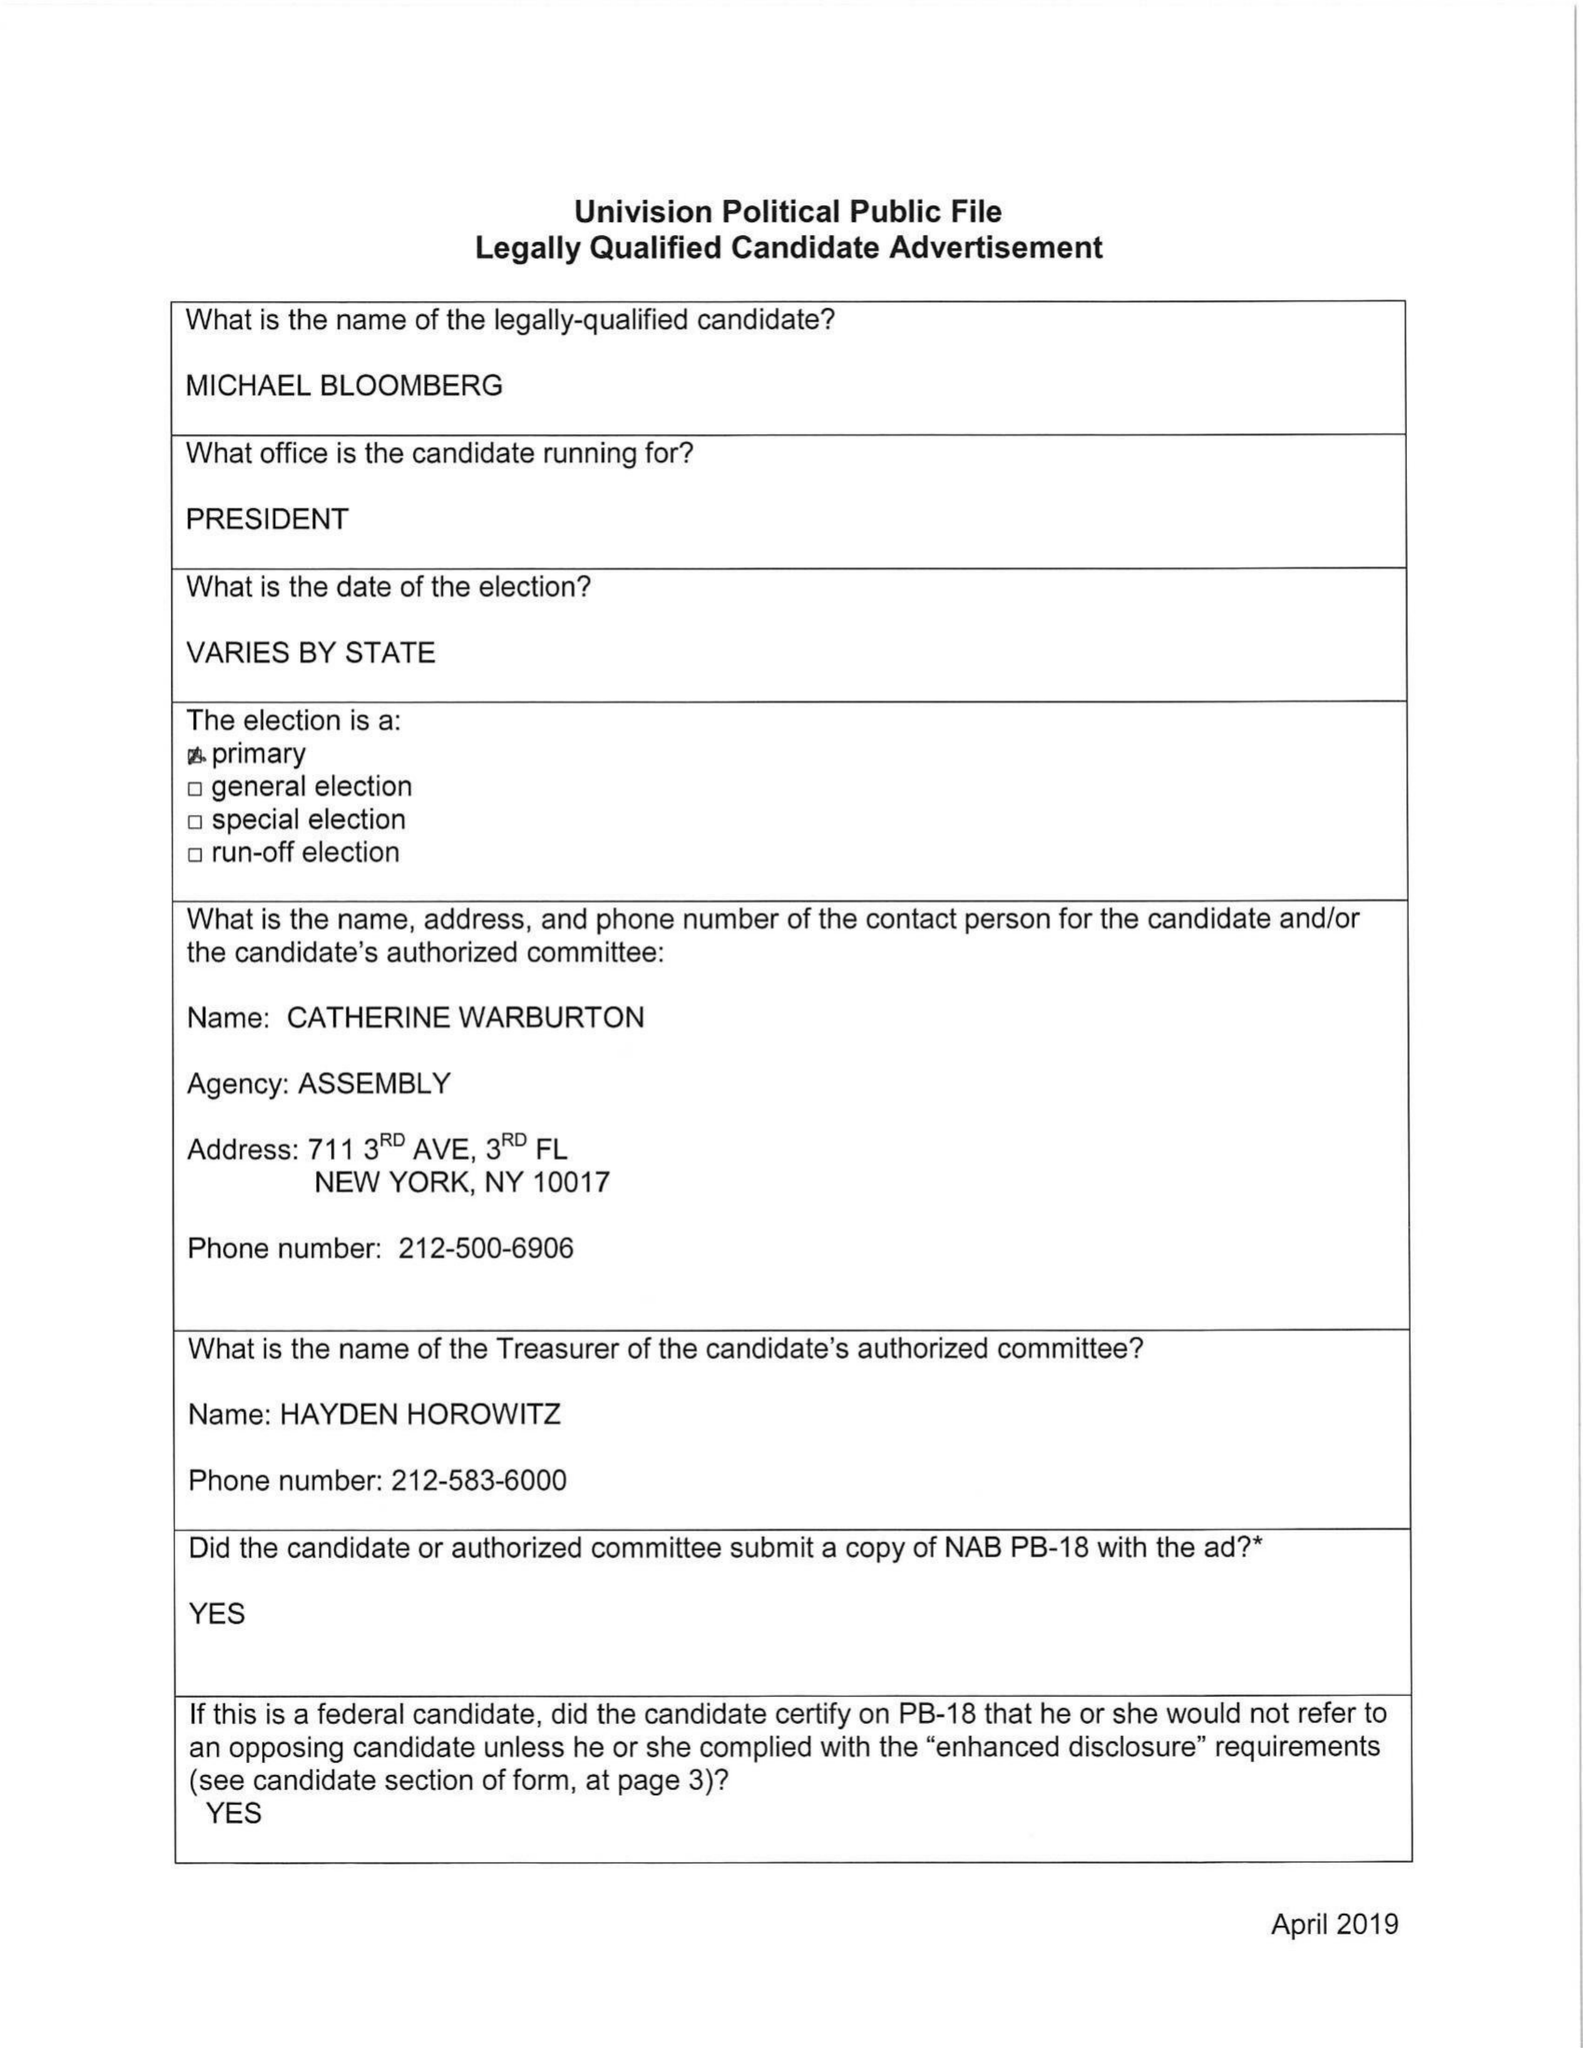What is the value for the advertiser?
Answer the question using a single word or phrase. MICHAEL BLOOMBERG 